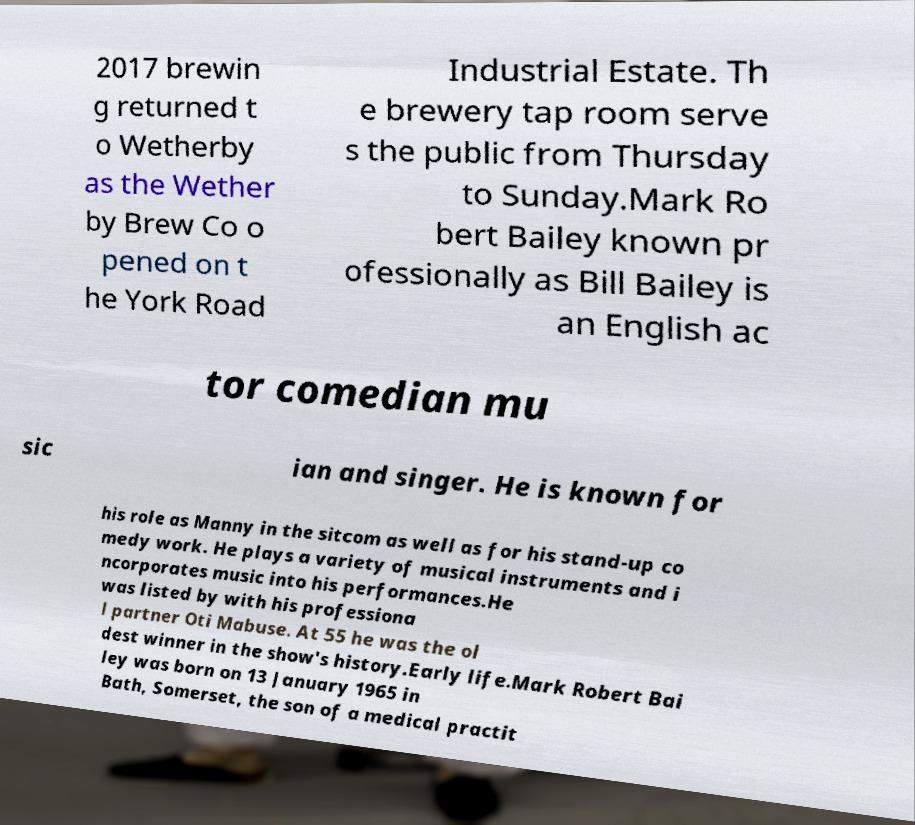For documentation purposes, I need the text within this image transcribed. Could you provide that? 2017 brewin g returned t o Wetherby as the Wether by Brew Co o pened on t he York Road Industrial Estate. Th e brewery tap room serve s the public from Thursday to Sunday.Mark Ro bert Bailey known pr ofessionally as Bill Bailey is an English ac tor comedian mu sic ian and singer. He is known for his role as Manny in the sitcom as well as for his stand-up co medy work. He plays a variety of musical instruments and i ncorporates music into his performances.He was listed by with his professiona l partner Oti Mabuse. At 55 he was the ol dest winner in the show's history.Early life.Mark Robert Bai ley was born on 13 January 1965 in Bath, Somerset, the son of a medical practit 